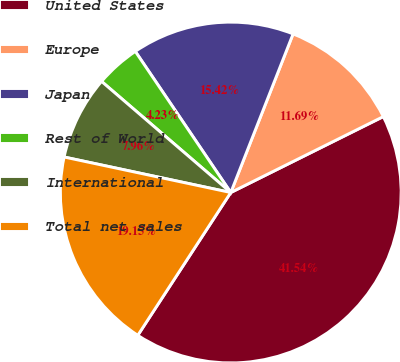Convert chart to OTSL. <chart><loc_0><loc_0><loc_500><loc_500><pie_chart><fcel>United States<fcel>Europe<fcel>Japan<fcel>Rest of World<fcel>International<fcel>Total net sales<nl><fcel>41.53%<fcel>11.69%<fcel>15.42%<fcel>4.23%<fcel>7.96%<fcel>19.15%<nl></chart> 